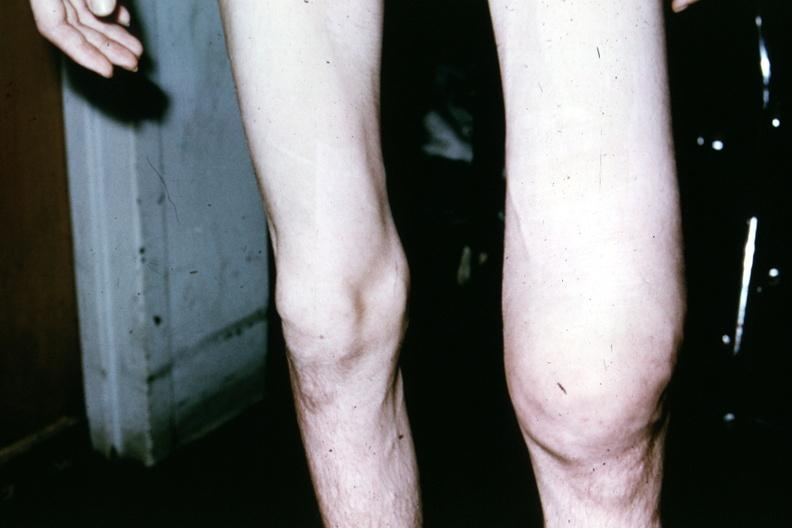does this image show patient before surgery showing both knees 18yo male?
Answer the question using a single word or phrase. Yes 